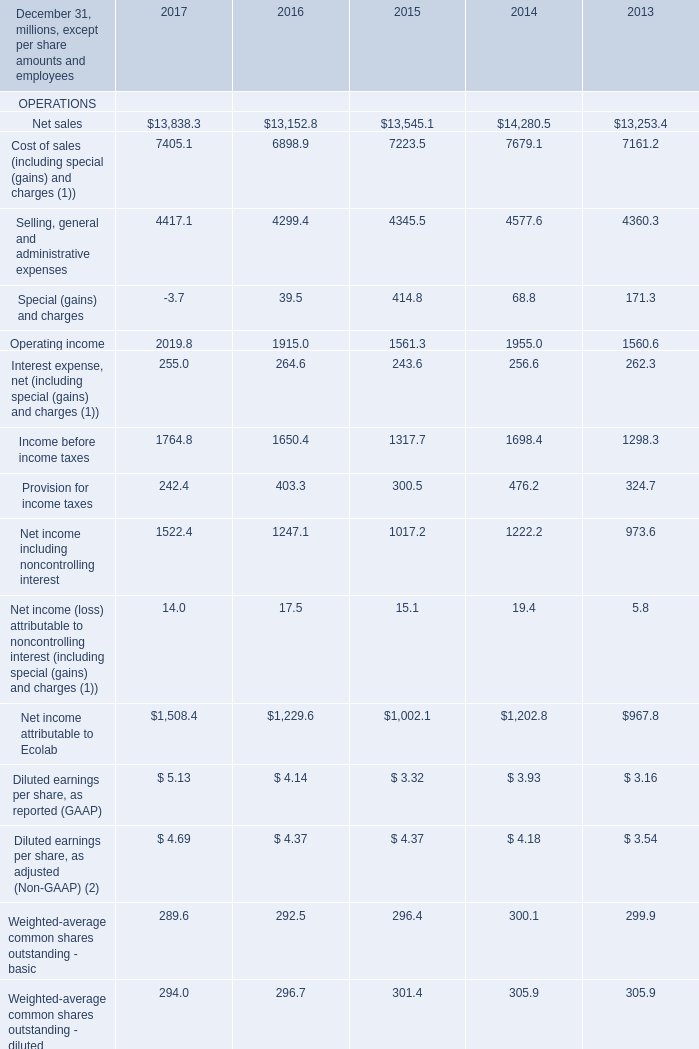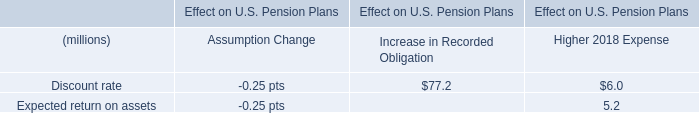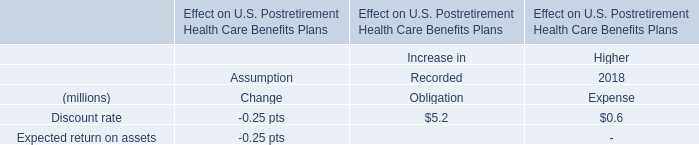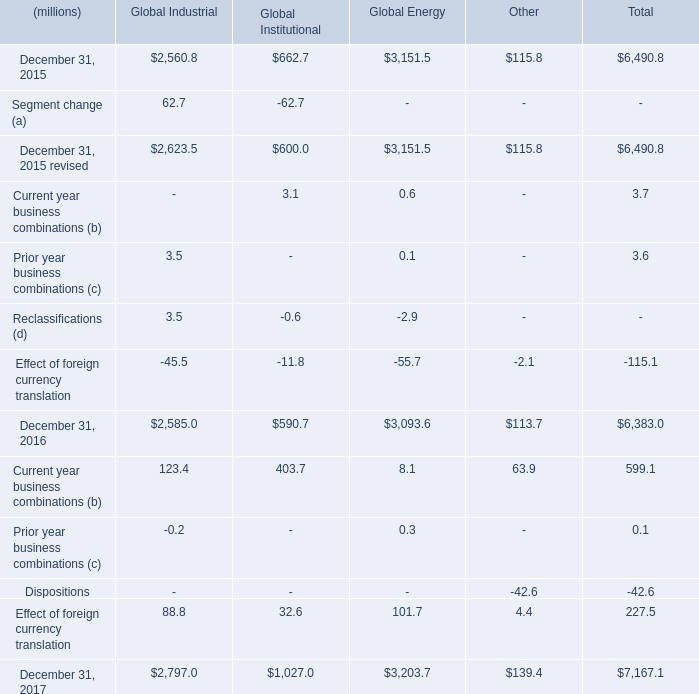What is the sum of December 31, 2015 revised of Global Industrial, Current liabilities FINANCIAL POSITION of 2013, and Total liabilities and equity FINANCIAL POSITION of 2017 ? 
Computations: ((2623.5 + 3487.5) + 19962.4)
Answer: 26073.4. 